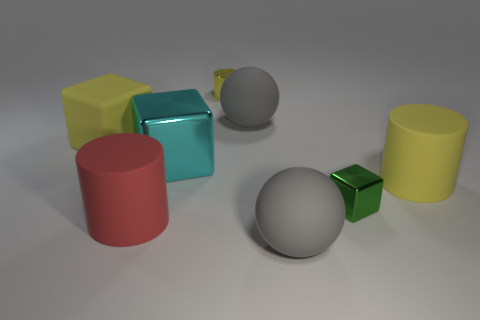There is a small object that is the same color as the rubber cube; what shape is it?
Give a very brief answer. Cylinder. The metallic thing that is the same color as the large matte block is what size?
Make the answer very short. Small. There is a large block that is the same color as the metallic cylinder; what is its material?
Keep it short and to the point. Rubber. Do the yellow metallic thing and the green cube in front of the large rubber block have the same size?
Keep it short and to the point. Yes. What is the color of the rubber cylinder that is on the right side of the gray matte thing behind the large rubber cube?
Give a very brief answer. Yellow. How many objects are either large yellow rubber cylinders in front of the small yellow metal object or cubes that are on the left side of the small green object?
Your response must be concise. 3. Does the red cylinder have the same size as the green shiny object?
Your response must be concise. No. Does the yellow rubber thing in front of the yellow block have the same shape as the small metallic thing left of the small metal block?
Provide a short and direct response. Yes. The cyan metallic object has what size?
Your answer should be very brief. Large. What material is the yellow cylinder that is behind the gray rubber thing behind the big rubber cylinder in front of the green metal object?
Keep it short and to the point. Metal. 